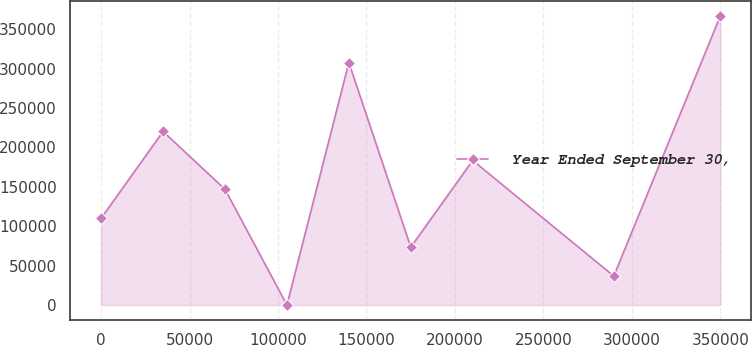Convert chart. <chart><loc_0><loc_0><loc_500><loc_500><line_chart><ecel><fcel>Year Ended September 30,<nl><fcel>44.67<fcel>110149<nl><fcel>35047.1<fcel>220151<nl><fcel>70049.5<fcel>146816<nl><fcel>105052<fcel>147.82<nl><fcel>140054<fcel>307512<nl><fcel>175057<fcel>73482.1<nl><fcel>210059<fcel>183483<nl><fcel>289809<fcel>36814.9<nl><fcel>350069<fcel>366819<nl></chart> 